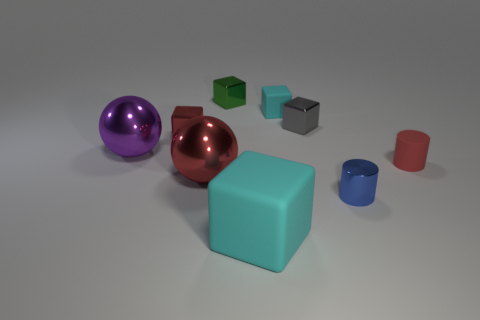Subtract all large blocks. How many blocks are left? 4 Subtract all gray blocks. How many blocks are left? 4 Subtract all cubes. How many objects are left? 4 Add 5 large shiny cubes. How many large shiny cubes exist? 5 Subtract 0 purple blocks. How many objects are left? 9 Subtract 1 cylinders. How many cylinders are left? 1 Subtract all cyan cylinders. Subtract all yellow balls. How many cylinders are left? 2 Subtract all purple blocks. How many red cylinders are left? 1 Subtract all tiny cyan objects. Subtract all small red shiny objects. How many objects are left? 7 Add 5 gray metal cubes. How many gray metal cubes are left? 6 